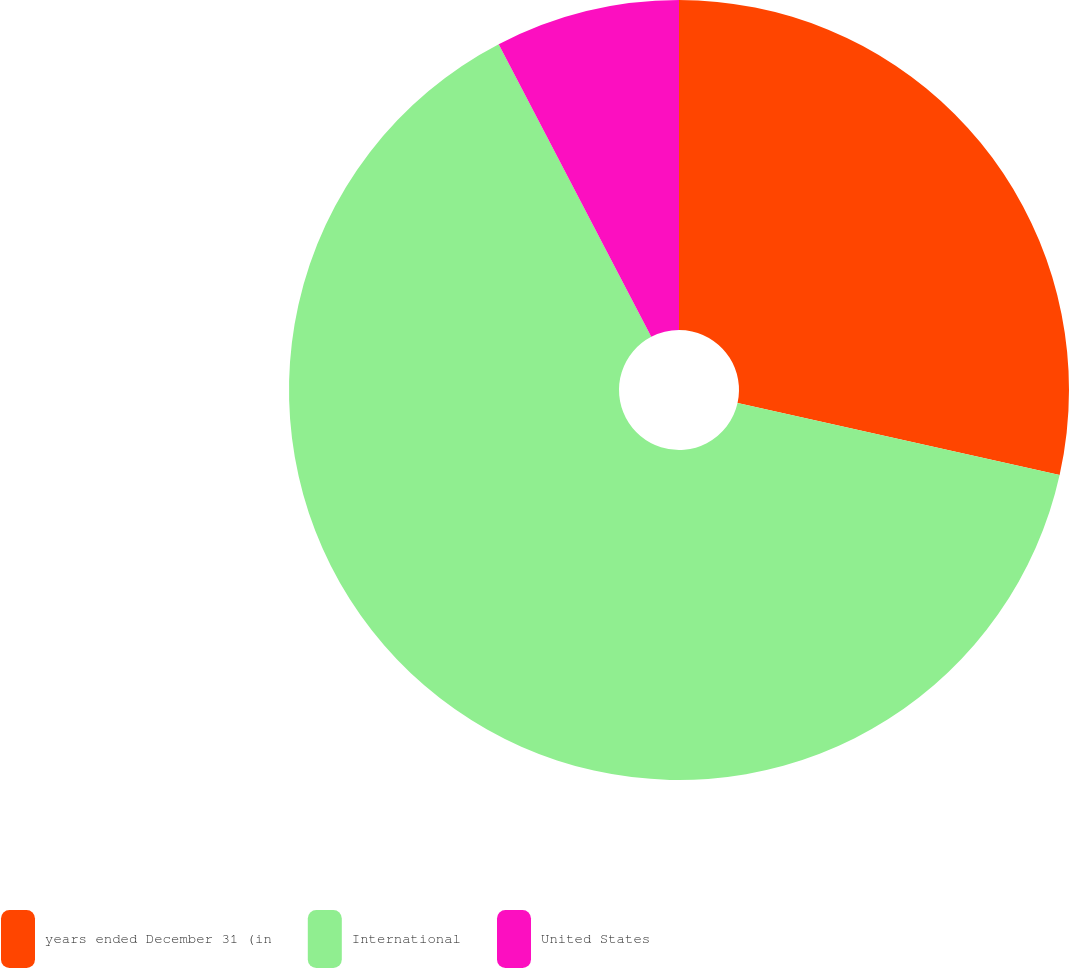Convert chart. <chart><loc_0><loc_0><loc_500><loc_500><pie_chart><fcel>years ended December 31 (in<fcel>International<fcel>United States<nl><fcel>28.5%<fcel>63.85%<fcel>7.65%<nl></chart> 